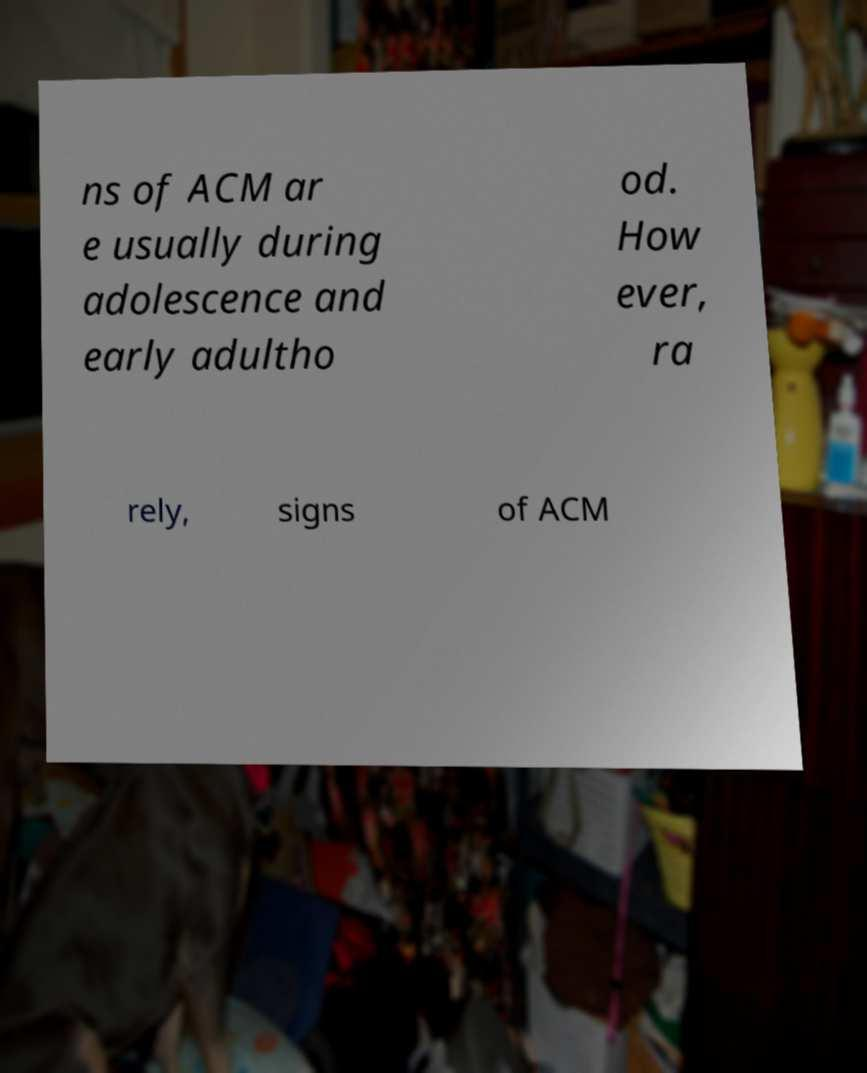There's text embedded in this image that I need extracted. Can you transcribe it verbatim? ns of ACM ar e usually during adolescence and early adultho od. How ever, ra rely, signs of ACM 